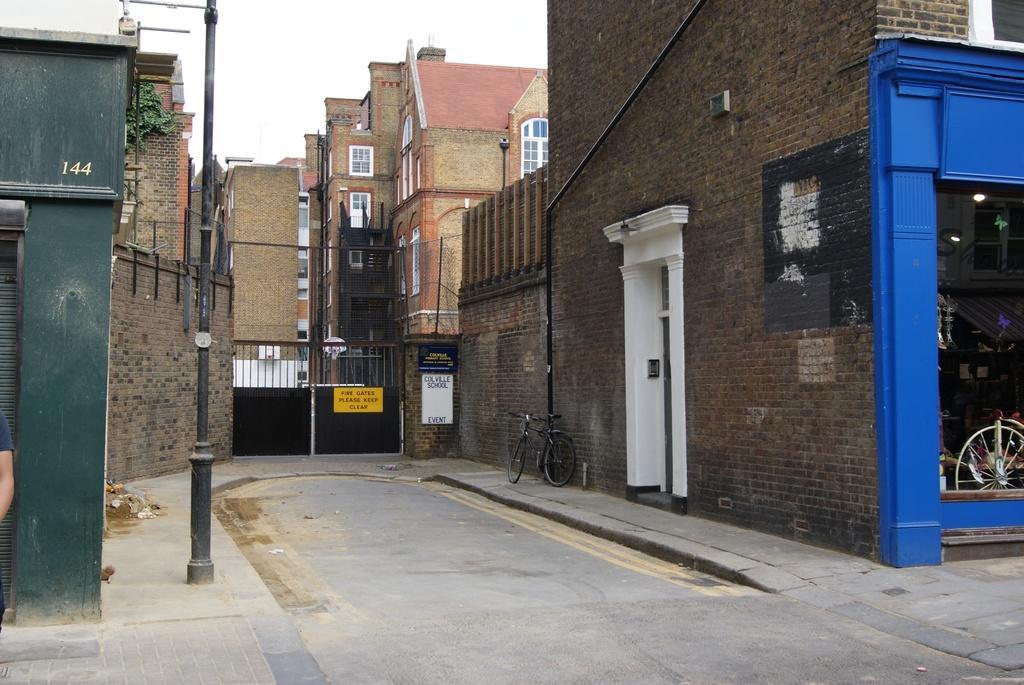In one or two sentences, can you explain what this image depicts? This picture might be taken from outside of the city. In this image, on the right side, we can see a building, glass window. In the glass window, we can also see a pedal of a bicycle, out of the building, we can see a bicycle, board. On the left side, we can see a pole, street light, shutter, brick wall, we can also see hand of a person. In the middle of the image, we can see a metal door, board. In the background, we can see some buildings. On the top, we can see a sky, at the bottom there is a road and a footpath. 